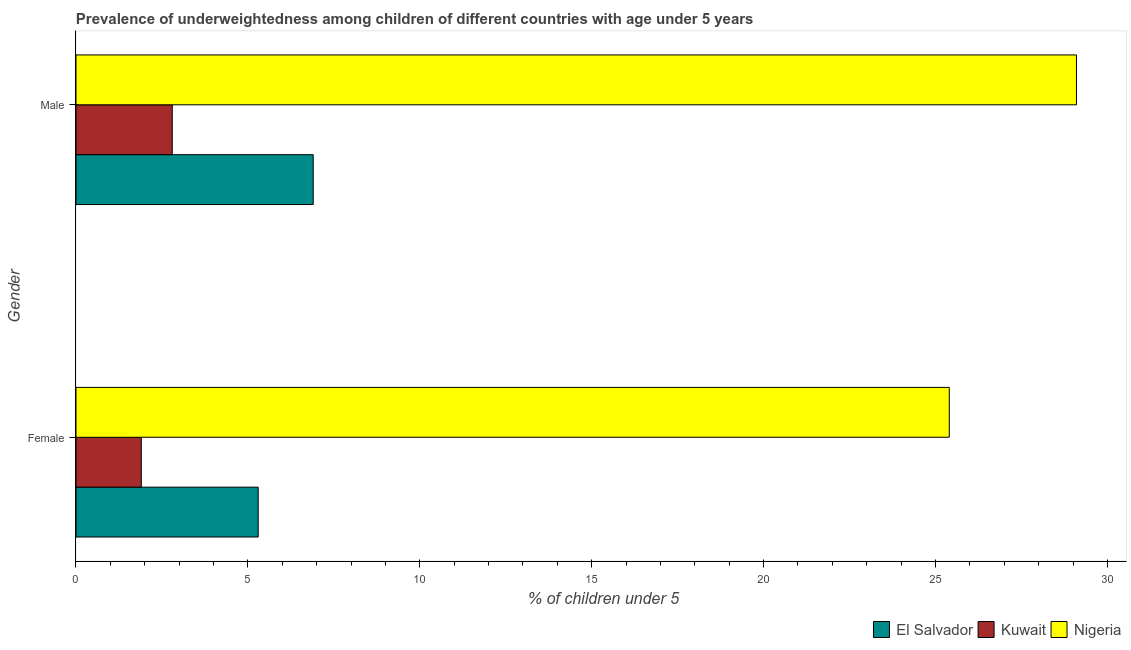How many different coloured bars are there?
Give a very brief answer. 3. What is the label of the 2nd group of bars from the top?
Your response must be concise. Female. What is the percentage of underweighted female children in Kuwait?
Keep it short and to the point. 1.9. Across all countries, what is the maximum percentage of underweighted female children?
Make the answer very short. 25.4. Across all countries, what is the minimum percentage of underweighted male children?
Offer a terse response. 2.8. In which country was the percentage of underweighted male children maximum?
Provide a succinct answer. Nigeria. In which country was the percentage of underweighted male children minimum?
Your response must be concise. Kuwait. What is the total percentage of underweighted female children in the graph?
Make the answer very short. 32.6. What is the difference between the percentage of underweighted male children in El Salvador and that in Nigeria?
Your answer should be compact. -22.2. What is the difference between the percentage of underweighted female children in Nigeria and the percentage of underweighted male children in Kuwait?
Provide a short and direct response. 22.6. What is the average percentage of underweighted male children per country?
Make the answer very short. 12.93. What is the difference between the percentage of underweighted female children and percentage of underweighted male children in Kuwait?
Offer a terse response. -0.9. In how many countries, is the percentage of underweighted female children greater than 9 %?
Your response must be concise. 1. What is the ratio of the percentage of underweighted female children in Kuwait to that in El Salvador?
Keep it short and to the point. 0.36. Is the percentage of underweighted female children in Kuwait less than that in El Salvador?
Ensure brevity in your answer.  Yes. In how many countries, is the percentage of underweighted female children greater than the average percentage of underweighted female children taken over all countries?
Your response must be concise. 1. What does the 2nd bar from the top in Female represents?
Provide a succinct answer. Kuwait. What does the 2nd bar from the bottom in Male represents?
Your answer should be compact. Kuwait. How many bars are there?
Your response must be concise. 6. What is the difference between two consecutive major ticks on the X-axis?
Keep it short and to the point. 5. Does the graph contain grids?
Give a very brief answer. No. What is the title of the graph?
Offer a terse response. Prevalence of underweightedness among children of different countries with age under 5 years. What is the label or title of the X-axis?
Your answer should be compact.  % of children under 5. What is the  % of children under 5 of El Salvador in Female?
Keep it short and to the point. 5.3. What is the  % of children under 5 of Kuwait in Female?
Keep it short and to the point. 1.9. What is the  % of children under 5 in Nigeria in Female?
Offer a terse response. 25.4. What is the  % of children under 5 of El Salvador in Male?
Offer a very short reply. 6.9. What is the  % of children under 5 in Kuwait in Male?
Give a very brief answer. 2.8. What is the  % of children under 5 in Nigeria in Male?
Your response must be concise. 29.1. Across all Gender, what is the maximum  % of children under 5 in El Salvador?
Offer a terse response. 6.9. Across all Gender, what is the maximum  % of children under 5 in Kuwait?
Ensure brevity in your answer.  2.8. Across all Gender, what is the maximum  % of children under 5 in Nigeria?
Offer a very short reply. 29.1. Across all Gender, what is the minimum  % of children under 5 of El Salvador?
Your answer should be compact. 5.3. Across all Gender, what is the minimum  % of children under 5 in Kuwait?
Provide a succinct answer. 1.9. Across all Gender, what is the minimum  % of children under 5 of Nigeria?
Your answer should be compact. 25.4. What is the total  % of children under 5 in Nigeria in the graph?
Make the answer very short. 54.5. What is the difference between the  % of children under 5 in El Salvador in Female and that in Male?
Ensure brevity in your answer.  -1.6. What is the difference between the  % of children under 5 of El Salvador in Female and the  % of children under 5 of Kuwait in Male?
Ensure brevity in your answer.  2.5. What is the difference between the  % of children under 5 of El Salvador in Female and the  % of children under 5 of Nigeria in Male?
Give a very brief answer. -23.8. What is the difference between the  % of children under 5 in Kuwait in Female and the  % of children under 5 in Nigeria in Male?
Give a very brief answer. -27.2. What is the average  % of children under 5 in Kuwait per Gender?
Offer a terse response. 2.35. What is the average  % of children under 5 of Nigeria per Gender?
Provide a succinct answer. 27.25. What is the difference between the  % of children under 5 in El Salvador and  % of children under 5 in Nigeria in Female?
Provide a short and direct response. -20.1. What is the difference between the  % of children under 5 in Kuwait and  % of children under 5 in Nigeria in Female?
Ensure brevity in your answer.  -23.5. What is the difference between the  % of children under 5 of El Salvador and  % of children under 5 of Kuwait in Male?
Keep it short and to the point. 4.1. What is the difference between the  % of children under 5 in El Salvador and  % of children under 5 in Nigeria in Male?
Offer a terse response. -22.2. What is the difference between the  % of children under 5 in Kuwait and  % of children under 5 in Nigeria in Male?
Make the answer very short. -26.3. What is the ratio of the  % of children under 5 of El Salvador in Female to that in Male?
Ensure brevity in your answer.  0.77. What is the ratio of the  % of children under 5 in Kuwait in Female to that in Male?
Your answer should be very brief. 0.68. What is the ratio of the  % of children under 5 in Nigeria in Female to that in Male?
Keep it short and to the point. 0.87. What is the difference between the highest and the second highest  % of children under 5 of El Salvador?
Give a very brief answer. 1.6. What is the difference between the highest and the second highest  % of children under 5 of Kuwait?
Your answer should be very brief. 0.9. What is the difference between the highest and the lowest  % of children under 5 of El Salvador?
Make the answer very short. 1.6. What is the difference between the highest and the lowest  % of children under 5 in Kuwait?
Give a very brief answer. 0.9. 